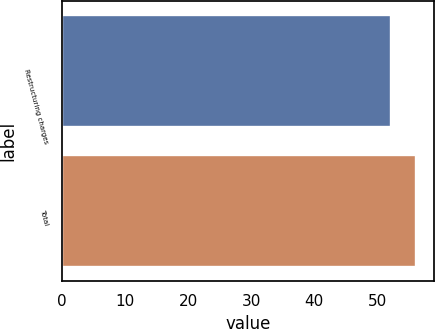<chart> <loc_0><loc_0><loc_500><loc_500><bar_chart><fcel>Restructuring charges<fcel>Total<nl><fcel>52.2<fcel>56.2<nl></chart> 